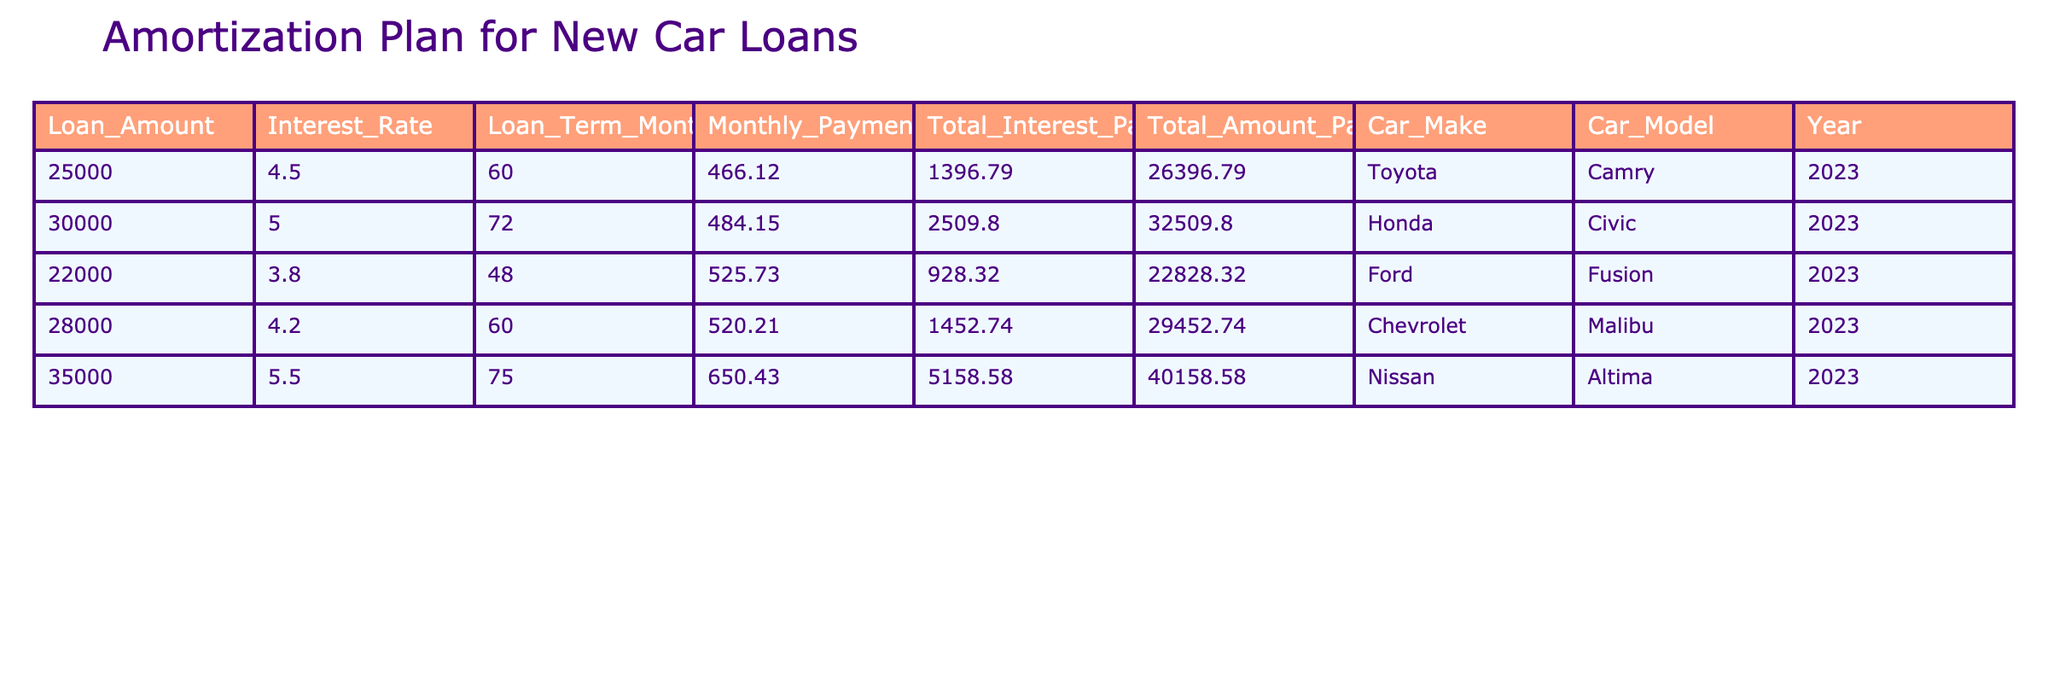What is the monthly payment for the Toyota Camry? The monthly payment is listed under the Monthly Payment column corresponding to the Toyota Camry row. The value is 466.12.
Answer: 466.12 Which car has the lowest total interest paid? By examining the Total Interest Paid column, the Ford Fusion has the lowest value of 928.32, which is less than the other cars listed.
Answer: Ford Fusion How much more is the total amount paid for the Honda Civic compared to the Ford Fusion? First, find the Total Amount Paid for both cars. The Honda Civic's total is 32509.80, and the Ford Fusion's total is 22828.32. The difference is calculated as 32509.80 - 22828.32 = 9681.48.
Answer: 9681.48 Is the Nissan Altima the most expensive car in terms of total amount paid? To determine this, we need to check the Total Amount Paid column. The Nissan Altima's amount is 40158.58, and checking the other cars shows it is indeed the highest total amount.
Answer: Yes What is the average monthly payment of the cars listed? First, sum the monthly payments: 466.12 + 484.15 + 525.73 + 520.21 + 650.43 = 2646.64. Then, divide by the total number of cars, which is 5. Thus, the average is 2646.64 / 5 = 529.33.
Answer: 529.33 Which car has the longest loan term, and what is its term in months? Looking at the Loan Term Months column, the Nissan Altima has the highest value of 75 months, which is longer than the others.
Answer: Nissan Altima, 75 What is the total amount paid for the Chevrolet Malibu compared to the average total amount of all cars? First, the total for the Chevrolet Malibu is 29452.74. Next, calculate the average total amount: (26396.79 + 32509.80 + 22828.32 + 29452.74 + 40158.58) / 5 = 30609.84. Comparing the two amounts shows that 29452.74 is lower than the average.
Answer: Lower What is the percentage of total interest paid relative to the total amount paid for the Ford Fusion? The total interest paid for the Ford Fusion is 928.32 and the total amount paid is 22828.32. To find the percentage, calculate (928.32 / 22828.32) * 100 = 4.06%.
Answer: 4.06% 